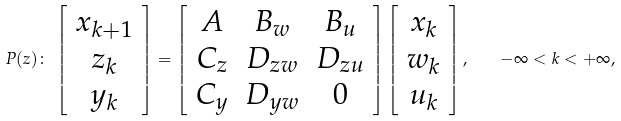Convert formula to latex. <formula><loc_0><loc_0><loc_500><loc_500>P ( z ) \colon \, \left [ \begin{array} { c } x _ { k + 1 } \\ z _ { k } \\ y _ { k } \end{array} \right ] = \left [ \begin{array} { c c c } A & B _ { w } & B _ { u } \\ C _ { z } & D _ { z w } & D _ { z u } \\ C _ { y } & D _ { y w } & 0 \end{array} \right ] \left [ \begin{array} { c } x _ { k } \\ w _ { k } \\ u _ { k } \end{array} \right ] , \quad - \infty < k < + \infty ,</formula> 